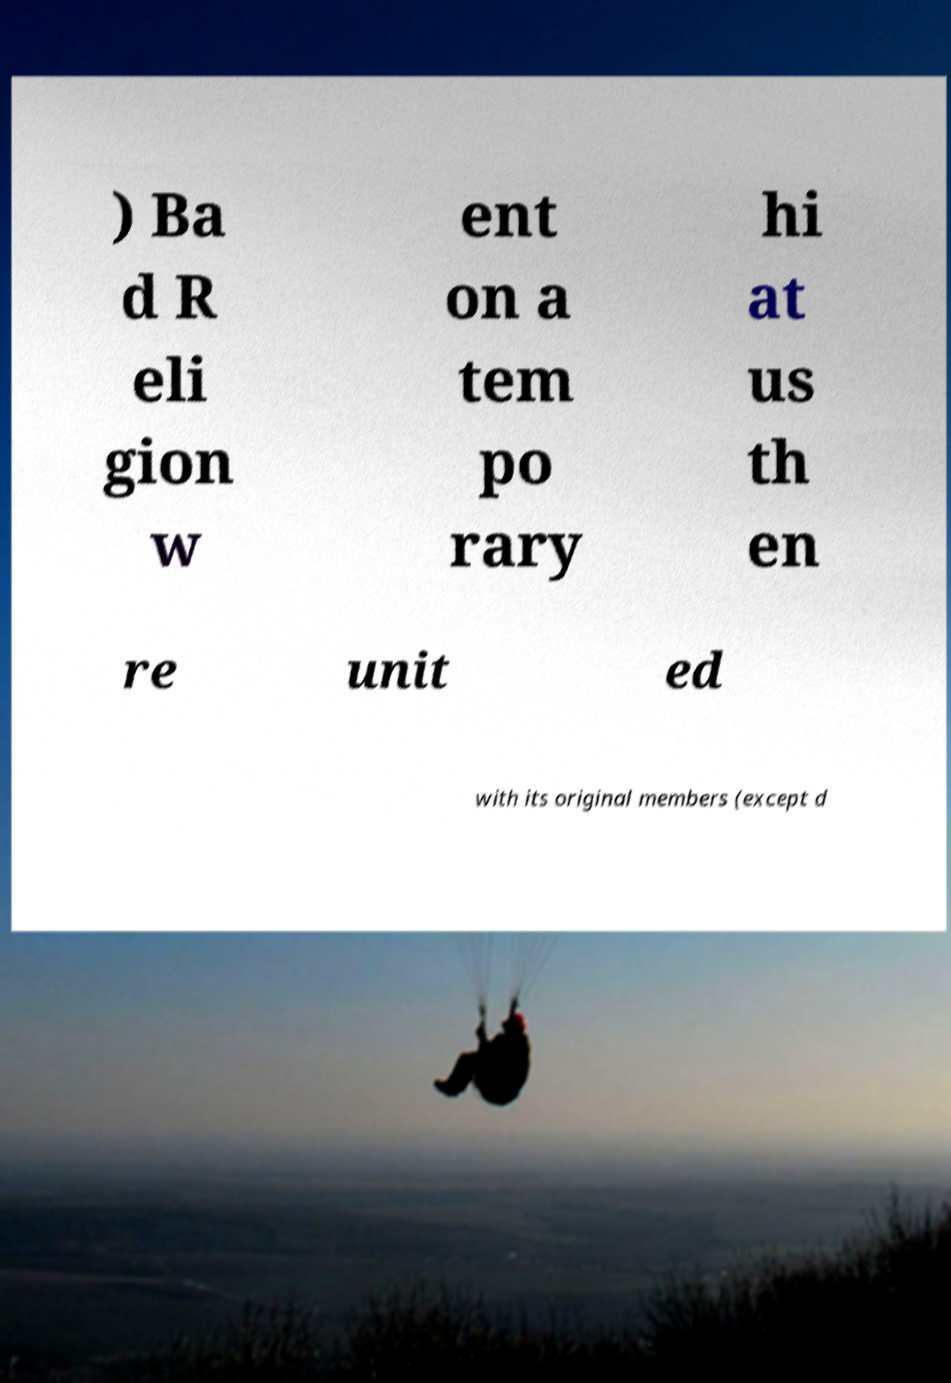Please identify and transcribe the text found in this image. ) Ba d R eli gion w ent on a tem po rary hi at us th en re unit ed with its original members (except d 